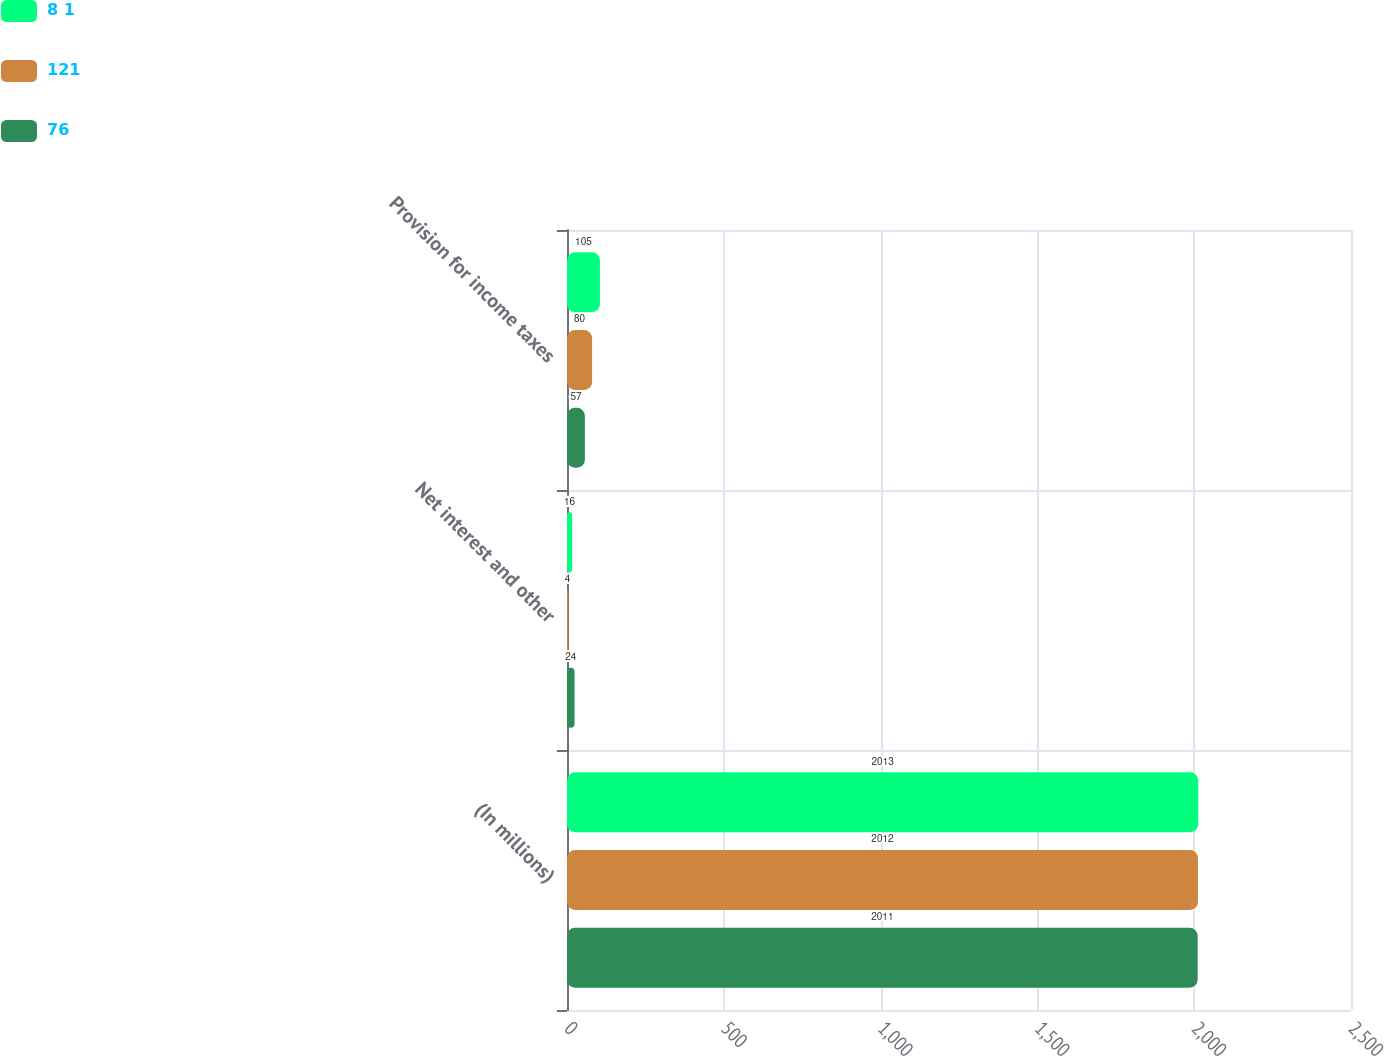Convert chart to OTSL. <chart><loc_0><loc_0><loc_500><loc_500><stacked_bar_chart><ecel><fcel>(In millions)<fcel>Net interest and other<fcel>Provision for income taxes<nl><fcel>8 1<fcel>2013<fcel>16<fcel>105<nl><fcel>121<fcel>2012<fcel>4<fcel>80<nl><fcel>76<fcel>2011<fcel>24<fcel>57<nl></chart> 